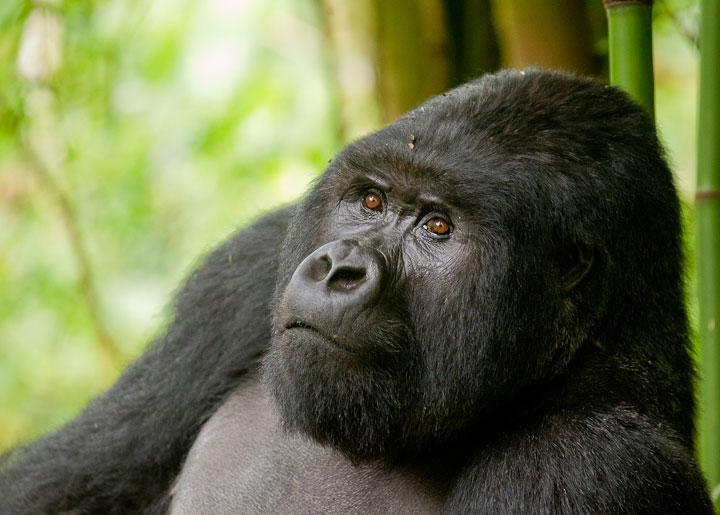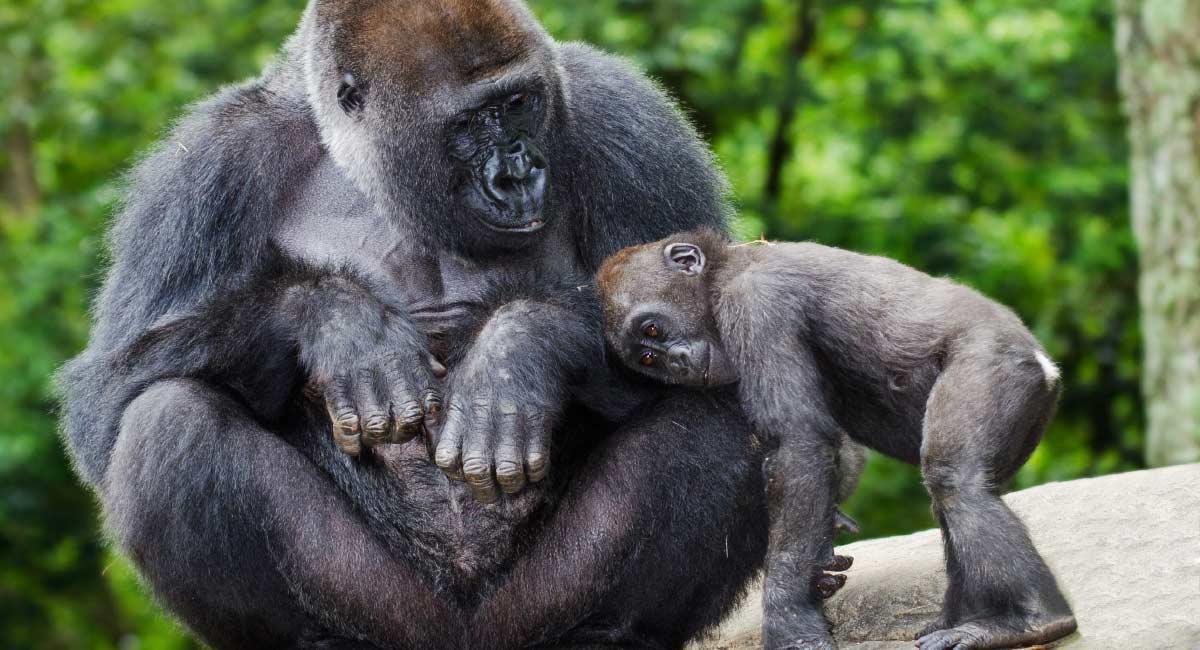The first image is the image on the left, the second image is the image on the right. Analyze the images presented: Is the assertion "There are three gorillas" valid? Answer yes or no. Yes. 